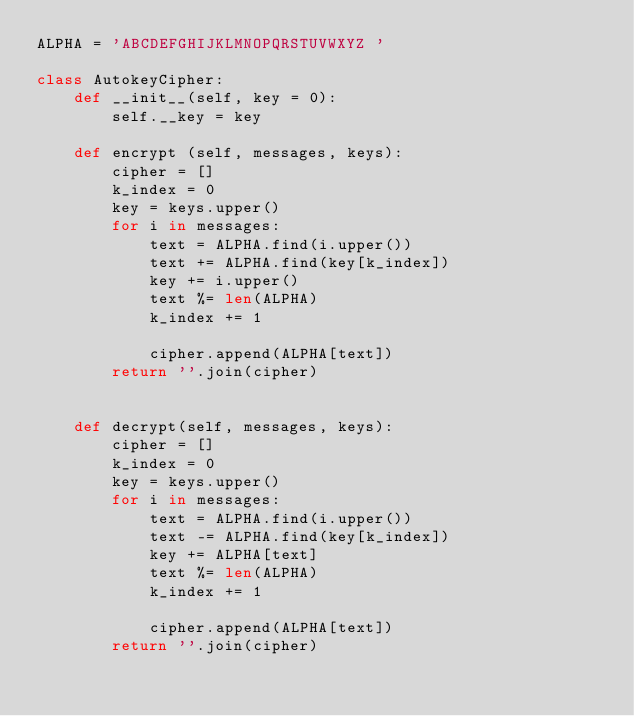Convert code to text. <code><loc_0><loc_0><loc_500><loc_500><_Python_>ALPHA = 'ABCDEFGHIJKLMNOPQRSTUVWXYZ '

class AutokeyCipher:
    def __init__(self, key = 0):
        self.__key = key

    def encrypt (self, messages, keys):  
        cipher = []
        k_index = 0
        key = keys.upper()
        for i in messages:
            text = ALPHA.find(i.upper())
            text += ALPHA.find(key[k_index])
            key += i.upper()
            text %= len(ALPHA)
            k_index += 1
    
            cipher.append(ALPHA[text])
        return ''.join(cipher)
            
            
    def decrypt(self, messages, keys):
        cipher = []
        k_index = 0
        key = keys.upper()
        for i in messages:
            text = ALPHA.find(i.upper())
            text -= ALPHA.find(key[k_index])
            key += ALPHA[text]
            text %= len(ALPHA)
            k_index += 1
    
            cipher.append(ALPHA[text])
        return ''.join(cipher)



        </code> 